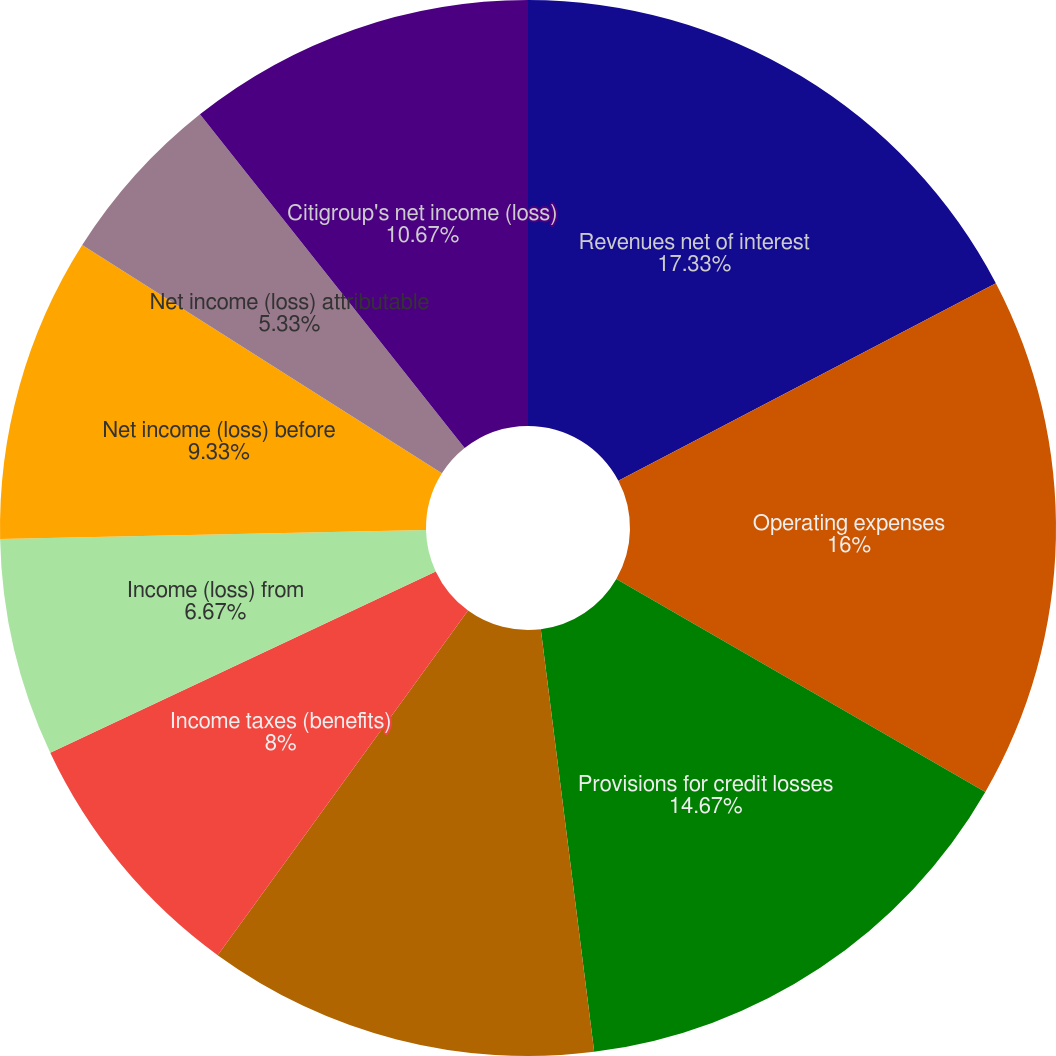Convert chart. <chart><loc_0><loc_0><loc_500><loc_500><pie_chart><fcel>Revenues net of interest<fcel>Operating expenses<fcel>Provisions for credit losses<fcel>Income (loss) from continuing<fcel>Income taxes (benefits)<fcel>Income (loss) from<fcel>Net income (loss) before<fcel>Net income (loss) attributable<fcel>Citigroup's net income (loss)<nl><fcel>17.33%<fcel>16.0%<fcel>14.67%<fcel>12.0%<fcel>8.0%<fcel>6.67%<fcel>9.33%<fcel>5.33%<fcel>10.67%<nl></chart> 